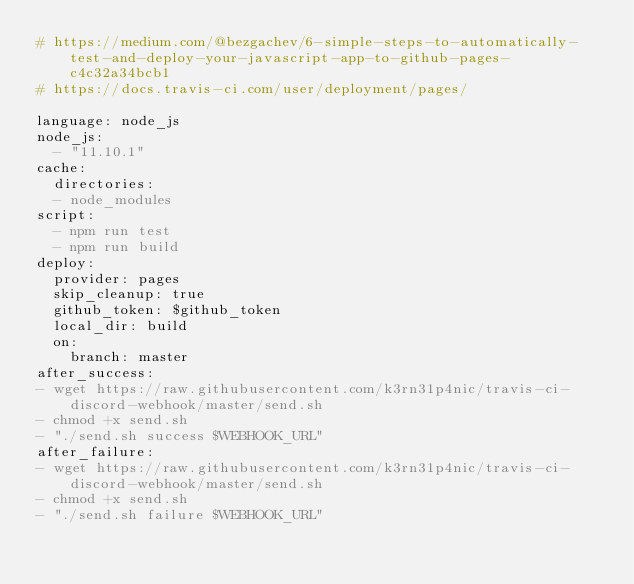<code> <loc_0><loc_0><loc_500><loc_500><_YAML_># https://medium.com/@bezgachev/6-simple-steps-to-automatically-test-and-deploy-your-javascript-app-to-github-pages-c4c32a34bcb1
# https://docs.travis-ci.com/user/deployment/pages/

language: node_js
node_js:
  - "11.10.1"
cache:
  directories:
  - node_modules
script:
  - npm run test
  - npm run build
deploy:
  provider: pages
  skip_cleanup: true
  github_token: $github_token
  local_dir: build
  on:
    branch: master
after_success:
- wget https://raw.githubusercontent.com/k3rn31p4nic/travis-ci-discord-webhook/master/send.sh
- chmod +x send.sh
- "./send.sh success $WEBHOOK_URL"
after_failure:
- wget https://raw.githubusercontent.com/k3rn31p4nic/travis-ci-discord-webhook/master/send.sh
- chmod +x send.sh
- "./send.sh failure $WEBHOOK_URL"
</code> 